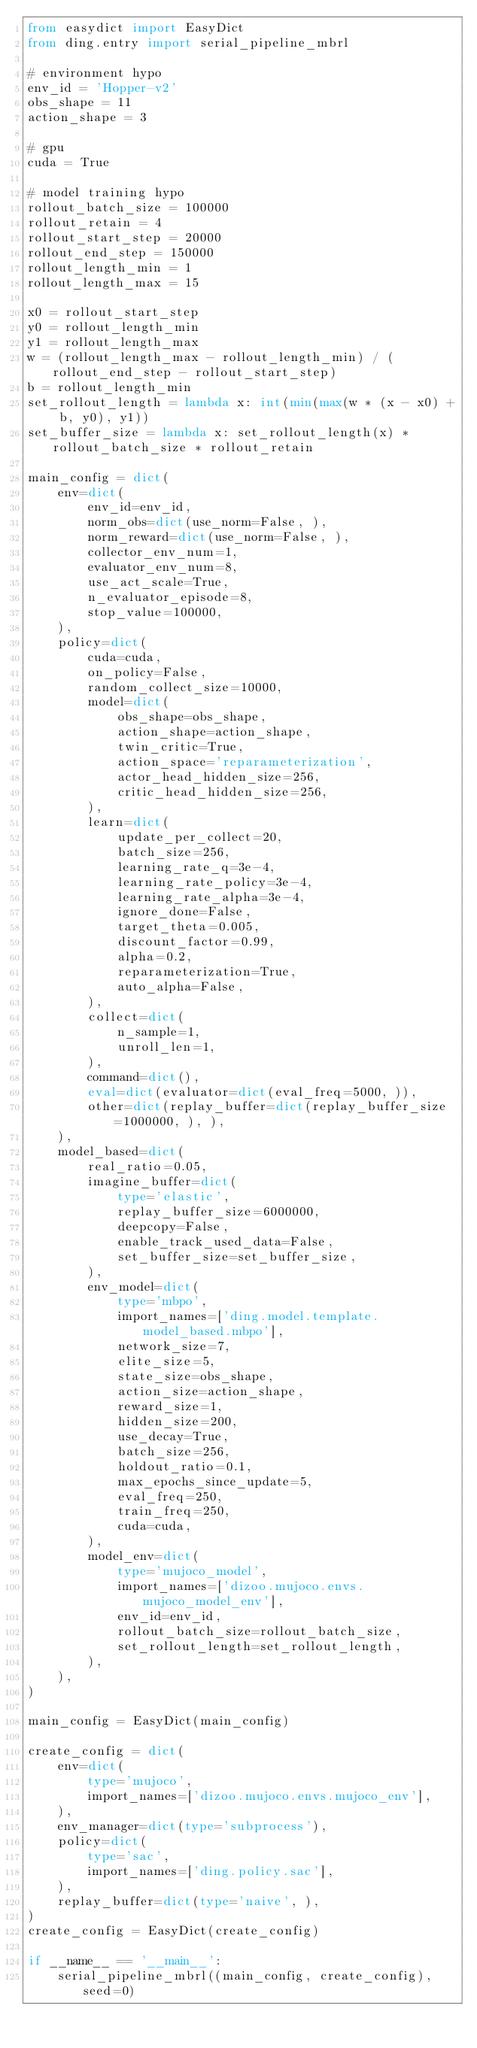Convert code to text. <code><loc_0><loc_0><loc_500><loc_500><_Python_>from easydict import EasyDict
from ding.entry import serial_pipeline_mbrl

# environment hypo
env_id = 'Hopper-v2'
obs_shape = 11
action_shape = 3

# gpu
cuda = True

# model training hypo
rollout_batch_size = 100000
rollout_retain = 4
rollout_start_step = 20000
rollout_end_step = 150000
rollout_length_min = 1
rollout_length_max = 15

x0 = rollout_start_step
y0 = rollout_length_min
y1 = rollout_length_max
w = (rollout_length_max - rollout_length_min) / (rollout_end_step - rollout_start_step)
b = rollout_length_min
set_rollout_length = lambda x: int(min(max(w * (x - x0) + b, y0), y1))
set_buffer_size = lambda x: set_rollout_length(x) * rollout_batch_size * rollout_retain

main_config = dict(
    env=dict(
        env_id=env_id,
        norm_obs=dict(use_norm=False, ),
        norm_reward=dict(use_norm=False, ),
        collector_env_num=1,
        evaluator_env_num=8,
        use_act_scale=True,
        n_evaluator_episode=8,
        stop_value=100000,
    ),
    policy=dict(
        cuda=cuda,
        on_policy=False,
        random_collect_size=10000,
        model=dict(
            obs_shape=obs_shape,
            action_shape=action_shape,
            twin_critic=True,
            action_space='reparameterization',
            actor_head_hidden_size=256,
            critic_head_hidden_size=256,
        ),
        learn=dict(
            update_per_collect=20,
            batch_size=256,
            learning_rate_q=3e-4,
            learning_rate_policy=3e-4,
            learning_rate_alpha=3e-4,
            ignore_done=False,
            target_theta=0.005,
            discount_factor=0.99,
            alpha=0.2,
            reparameterization=True,
            auto_alpha=False,
        ),
        collect=dict(
            n_sample=1,
            unroll_len=1,
        ),
        command=dict(),
        eval=dict(evaluator=dict(eval_freq=5000, )),
        other=dict(replay_buffer=dict(replay_buffer_size=1000000, ), ),
    ),
    model_based=dict(
        real_ratio=0.05,
        imagine_buffer=dict(
            type='elastic',
            replay_buffer_size=6000000,
            deepcopy=False,
            enable_track_used_data=False,
            set_buffer_size=set_buffer_size,
        ),
        env_model=dict(
            type='mbpo',
            import_names=['ding.model.template.model_based.mbpo'],
            network_size=7,
            elite_size=5,
            state_size=obs_shape,
            action_size=action_shape,
            reward_size=1,
            hidden_size=200,
            use_decay=True,
            batch_size=256,
            holdout_ratio=0.1,
            max_epochs_since_update=5,
            eval_freq=250,
            train_freq=250,
            cuda=cuda,
        ),
        model_env=dict(
            type='mujoco_model',
            import_names=['dizoo.mujoco.envs.mujoco_model_env'],
            env_id=env_id,
            rollout_batch_size=rollout_batch_size,
            set_rollout_length=set_rollout_length,
        ),
    ),
)

main_config = EasyDict(main_config)

create_config = dict(
    env=dict(
        type='mujoco',
        import_names=['dizoo.mujoco.envs.mujoco_env'],
    ),
    env_manager=dict(type='subprocess'),
    policy=dict(
        type='sac',
        import_names=['ding.policy.sac'],
    ),
    replay_buffer=dict(type='naive', ),
)
create_config = EasyDict(create_config)

if __name__ == '__main__':
    serial_pipeline_mbrl((main_config, create_config), seed=0)
</code> 